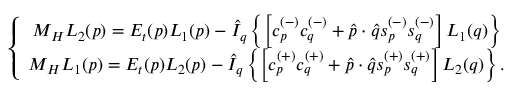<formula> <loc_0><loc_0><loc_500><loc_500>\left \{ \begin{array} { c } { { M _ { H } L _ { 2 } ( p ) = E _ { t } ( p ) L _ { 1 } ( p ) - \hat { I } _ { q } \left \{ \left [ c _ { p } ^ { ( - ) } c _ { q } ^ { ( - ) } + \hat { p } \cdot \hat { q } s _ { p } ^ { ( - ) } s _ { q } ^ { ( - ) } \right ] L _ { 1 } ( q ) \right \} } } \\ { { M _ { H } L _ { 1 } ( p ) = E _ { t } ( p ) L _ { 2 } ( p ) - \hat { I } _ { q } \left \{ \left [ c _ { p } ^ { ( + ) } c _ { q } ^ { ( + ) } + \hat { p } \cdot \hat { q } s _ { p } ^ { ( + ) } s _ { q } ^ { ( + ) } \right ] L _ { 2 } ( q ) \right \} . } } \end{array}</formula> 